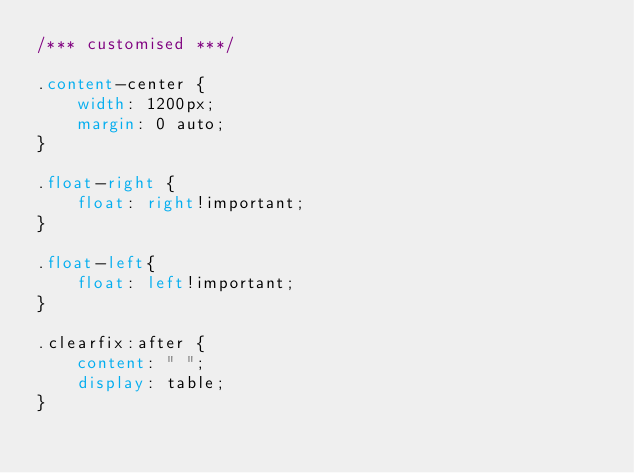<code> <loc_0><loc_0><loc_500><loc_500><_CSS_>/*** customised ***/

.content-center {
    width: 1200px;
    margin: 0 auto;
}

.float-right {
    float: right!important;
}

.float-left{
    float: left!important;
}

.clearfix:after {
    content: " ";
    display: table;
}</code> 